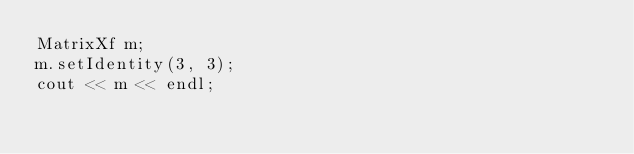Convert code to text. <code><loc_0><loc_0><loc_500><loc_500><_C++_>MatrixXf m;
m.setIdentity(3, 3);
cout << m << endl;
</code> 